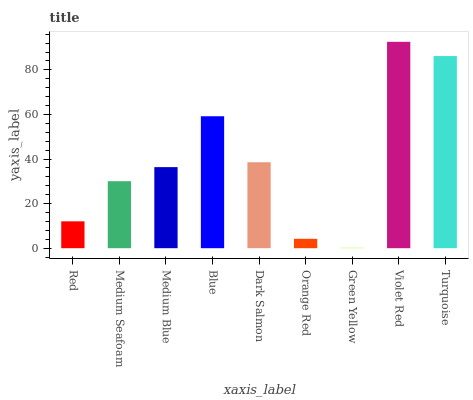Is Green Yellow the minimum?
Answer yes or no. Yes. Is Violet Red the maximum?
Answer yes or no. Yes. Is Medium Seafoam the minimum?
Answer yes or no. No. Is Medium Seafoam the maximum?
Answer yes or no. No. Is Medium Seafoam greater than Red?
Answer yes or no. Yes. Is Red less than Medium Seafoam?
Answer yes or no. Yes. Is Red greater than Medium Seafoam?
Answer yes or no. No. Is Medium Seafoam less than Red?
Answer yes or no. No. Is Medium Blue the high median?
Answer yes or no. Yes. Is Medium Blue the low median?
Answer yes or no. Yes. Is Blue the high median?
Answer yes or no. No. Is Red the low median?
Answer yes or no. No. 